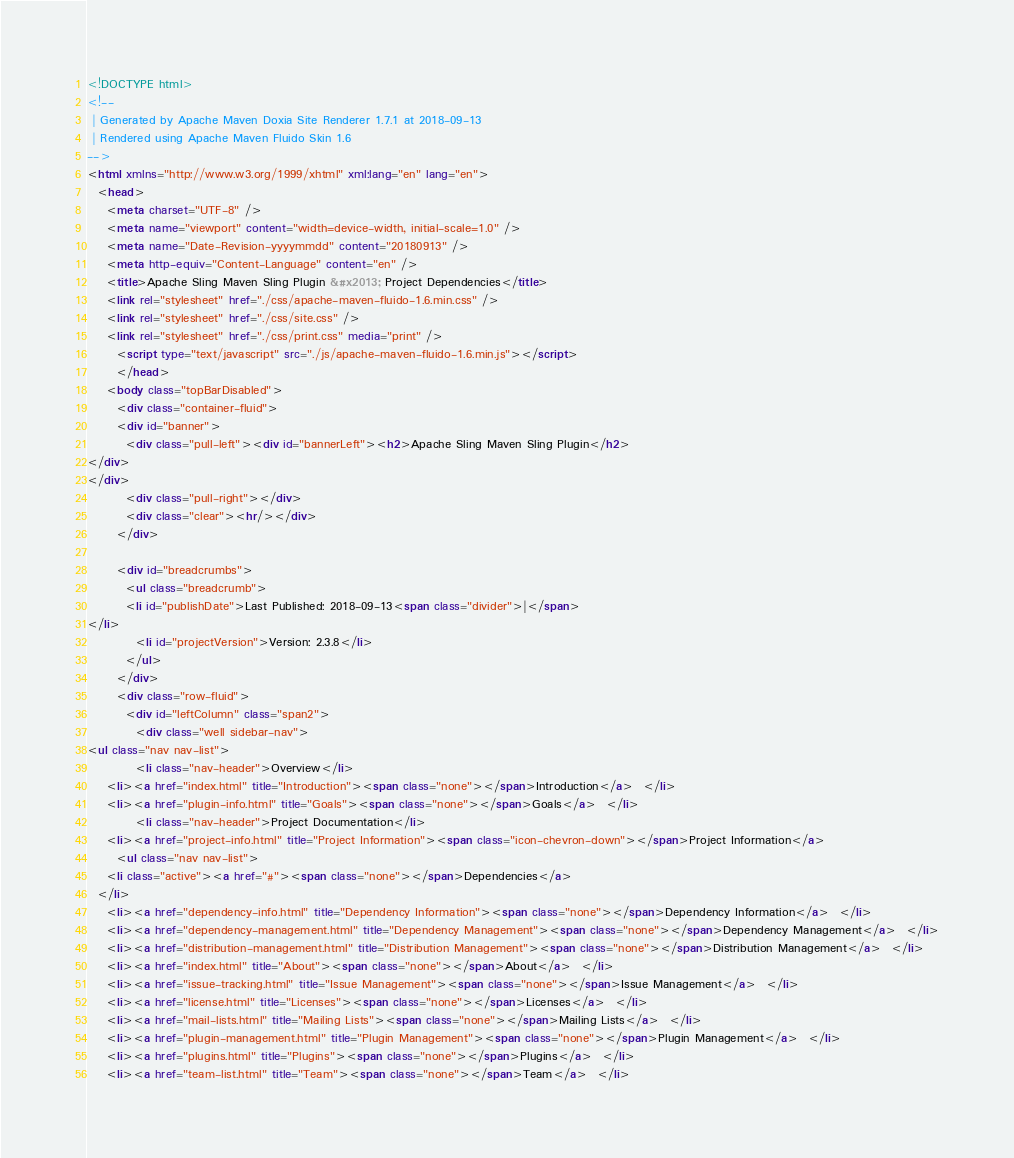<code> <loc_0><loc_0><loc_500><loc_500><_HTML_><!DOCTYPE html>
<!--
 | Generated by Apache Maven Doxia Site Renderer 1.7.1 at 2018-09-13 
 | Rendered using Apache Maven Fluido Skin 1.6
-->
<html xmlns="http://www.w3.org/1999/xhtml" xml:lang="en" lang="en">
  <head>
    <meta charset="UTF-8" />
    <meta name="viewport" content="width=device-width, initial-scale=1.0" />
    <meta name="Date-Revision-yyyymmdd" content="20180913" />
    <meta http-equiv="Content-Language" content="en" />
    <title>Apache Sling Maven Sling Plugin &#x2013; Project Dependencies</title>
    <link rel="stylesheet" href="./css/apache-maven-fluido-1.6.min.css" />
    <link rel="stylesheet" href="./css/site.css" />
    <link rel="stylesheet" href="./css/print.css" media="print" />
      <script type="text/javascript" src="./js/apache-maven-fluido-1.6.min.js"></script>
      </head>
    <body class="topBarDisabled">
      <div class="container-fluid">
      <div id="banner">
        <div class="pull-left"><div id="bannerLeft"><h2>Apache Sling Maven Sling Plugin</h2>
</div>
</div>
        <div class="pull-right"></div>
        <div class="clear"><hr/></div>
      </div>

      <div id="breadcrumbs">
        <ul class="breadcrumb">
        <li id="publishDate">Last Published: 2018-09-13<span class="divider">|</span>
</li>
          <li id="projectVersion">Version: 2.3.8</li>
        </ul>
      </div>
      <div class="row-fluid">
        <div id="leftColumn" class="span2">
          <div class="well sidebar-nav">
<ul class="nav nav-list">
          <li class="nav-header">Overview</li>
    <li><a href="index.html" title="Introduction"><span class="none"></span>Introduction</a>  </li>
    <li><a href="plugin-info.html" title="Goals"><span class="none"></span>Goals</a>  </li>
          <li class="nav-header">Project Documentation</li>
    <li><a href="project-info.html" title="Project Information"><span class="icon-chevron-down"></span>Project Information</a>
      <ul class="nav nav-list">
    <li class="active"><a href="#"><span class="none"></span>Dependencies</a>
  </li>
    <li><a href="dependency-info.html" title="Dependency Information"><span class="none"></span>Dependency Information</a>  </li>
    <li><a href="dependency-management.html" title="Dependency Management"><span class="none"></span>Dependency Management</a>  </li>
    <li><a href="distribution-management.html" title="Distribution Management"><span class="none"></span>Distribution Management</a>  </li>
    <li><a href="index.html" title="About"><span class="none"></span>About</a>  </li>
    <li><a href="issue-tracking.html" title="Issue Management"><span class="none"></span>Issue Management</a>  </li>
    <li><a href="license.html" title="Licenses"><span class="none"></span>Licenses</a>  </li>
    <li><a href="mail-lists.html" title="Mailing Lists"><span class="none"></span>Mailing Lists</a>  </li>
    <li><a href="plugin-management.html" title="Plugin Management"><span class="none"></span>Plugin Management</a>  </li>
    <li><a href="plugins.html" title="Plugins"><span class="none"></span>Plugins</a>  </li>
    <li><a href="team-list.html" title="Team"><span class="none"></span>Team</a>  </li></code> 